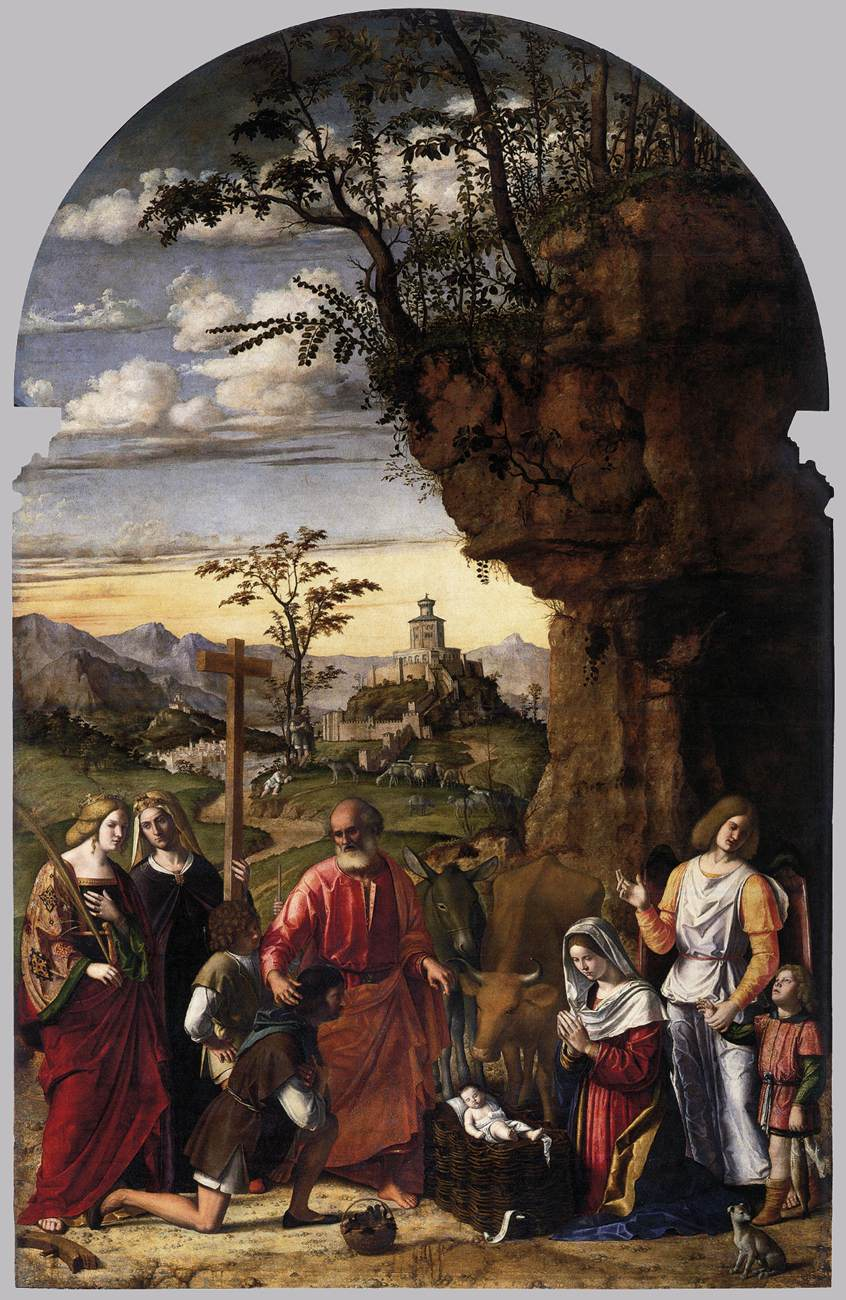If you could step into this painting, what would you experience? Stepping into this painting, you would find yourself enveloped in the solemn serenity of a sacred moment. The atmosphere would be filled with an almost tangible reverence as the group gathers around the Christ Child. The scent of pine and fresh earth would mix with the sounds of a nearby stream and the soft murmurs of prayer. The vibrant fabrics and intricate textures of the clothing and surrounding environment would capture your eye, while the expressions of awe and devotion on the figures' faces would resonate deeply, reminding you of the rich spiritual and cultural context of the era. Imagine the viewpoint of each figure in this painting – how might their thoughts and expressions differ? From the viewpoint of each figure, a unique tapestry of thoughts and emotions emerges. Mary, gazing at her newborn, would be filled with maternal love and sacred duty, her expression serene and introspective. Joseph's stern yet gentle demeanor would reflect his protective resolve and humility. The angels, embodiments of divine purity, would feel a transcendent joy, their expressions serene, holding a celestial calm. The shepherds, kneeling in humble adoration, would be in awe of the divine miracle before them, their rugged faces softening in profound reverence. Each figure contributes their own narrative, intertwining human emotion with divine prophecy, creating a multifaceted portrayal of this holy event. 